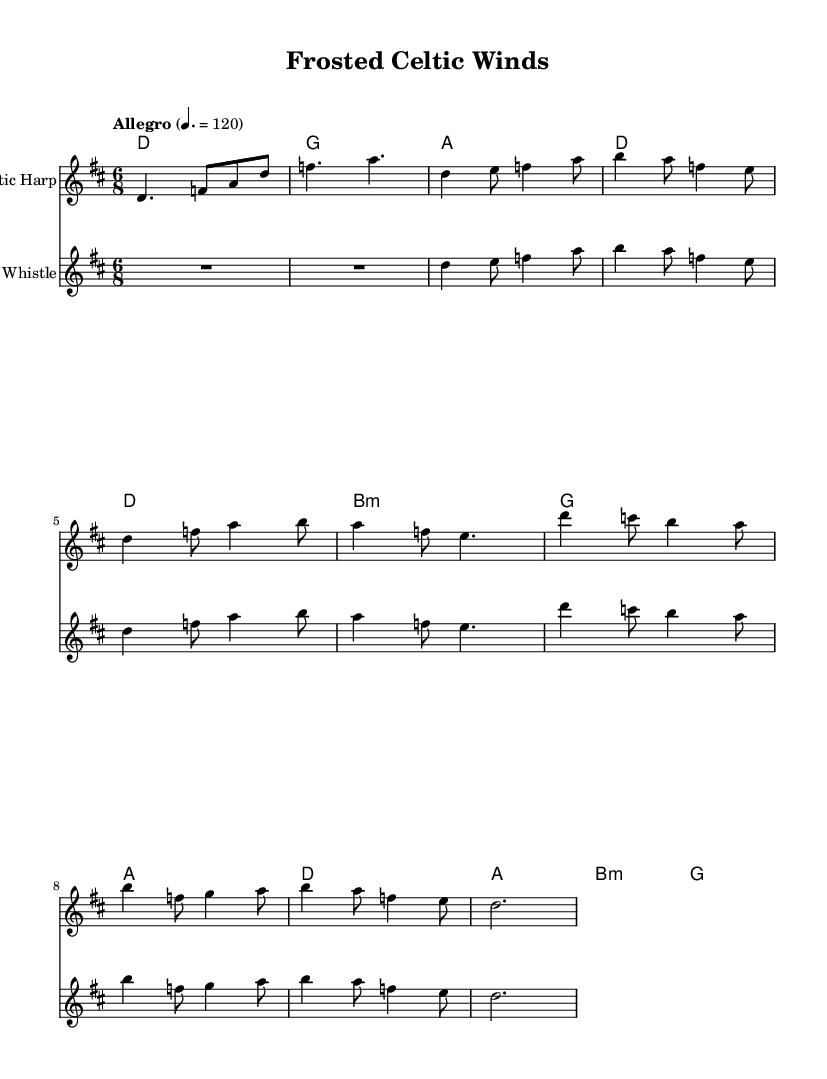What is the key signature of this music? The key signature is D major, which has two sharps (F# and C#). You can identify the key signature by looking at the beginning of the staff before the first note.
Answer: D major What is the time signature of this piece? The time signature is 6/8, which indicates that there are six eighth notes in each measure. This can be found at the beginning of the score next to the key signature.
Answer: 6/8 What is the tempo marking for this piece? The tempo marking is "Allegro," which indicates a fast tempo. Tempo indications are typically noted at the beginning of the score. The specific tempo is also provided as 120 beats per minute.
Answer: 120 How many measures are in the Intro section? The Intro consists of two measures. Each section can be identified by the notation and the length of the music prior to the verse.
Answer: 2 What type of instruments are used in the score? The instruments used are a Celtic Harp and a Tin Whistle, which can be seen indicated at the start of each staff in the score.
Answer: Celtic Harp and Tin Whistle Which section features the highest note? The Chorus section features the highest note, specifically D' in the staff, which is above the treble clef staff. This can be observed by comparing notes in different sections.
Answer: Chorus How many chords are in the Chorus section? The Chorus section has three chords: D, B minor, and G. By examining the chord names listed above the staff, you can count the distinct chords that correspond with this section.
Answer: 3 